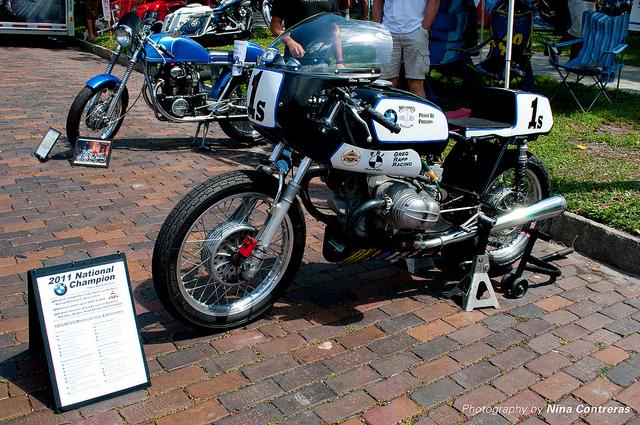What year is on the sign?
Quick response, please. 2011. What number is on the bike?
Give a very brief answer. 1. Are the bikes owned?
Write a very short answer. No. 